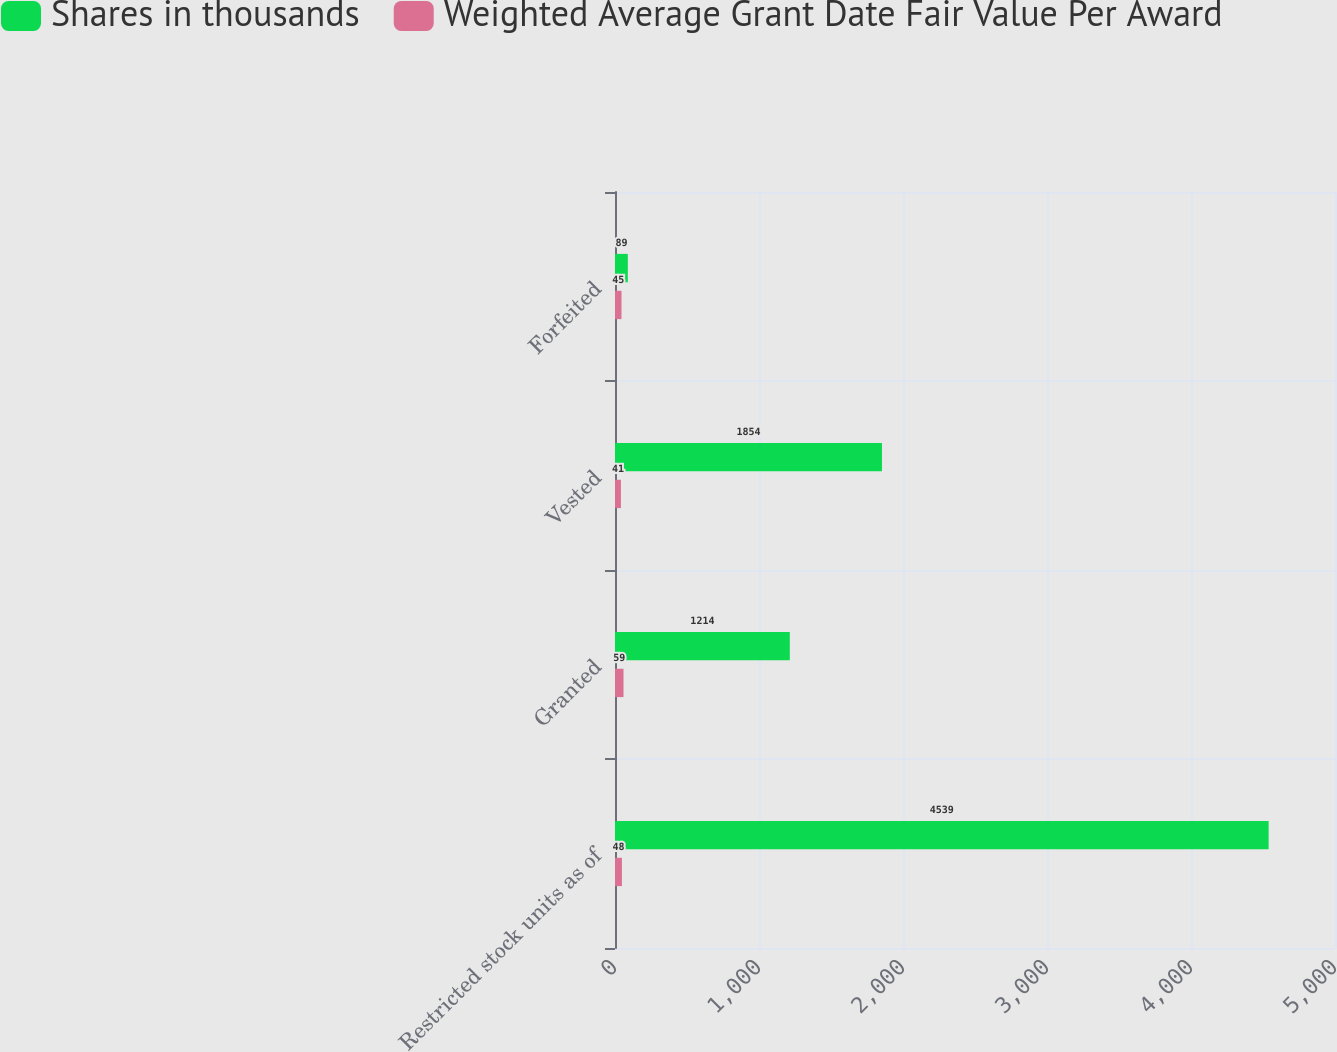Convert chart to OTSL. <chart><loc_0><loc_0><loc_500><loc_500><stacked_bar_chart><ecel><fcel>Restricted stock units as of<fcel>Granted<fcel>Vested<fcel>Forfeited<nl><fcel>Shares in thousands<fcel>4539<fcel>1214<fcel>1854<fcel>89<nl><fcel>Weighted Average Grant Date Fair Value Per Award<fcel>48<fcel>59<fcel>41<fcel>45<nl></chart> 